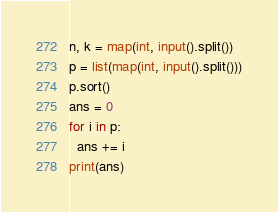<code> <loc_0><loc_0><loc_500><loc_500><_Python_>n, k = map(int, input().split())
p = list(map(int, input().split()))
p.sort()
ans = 0
for i in p:
  ans += i
print(ans)</code> 